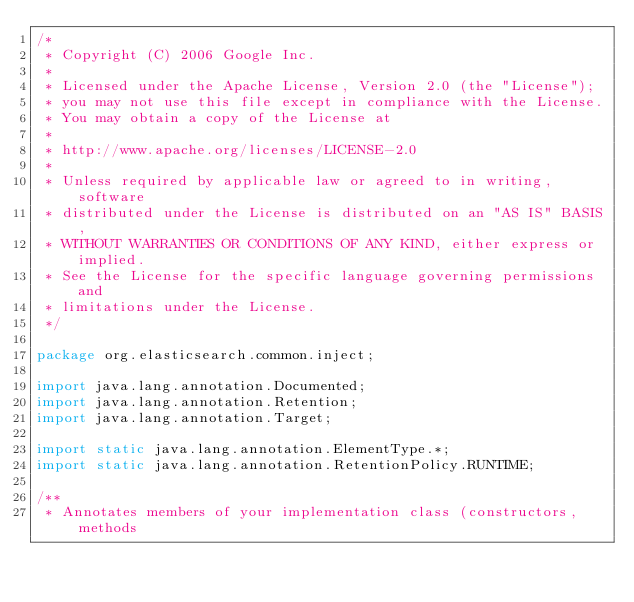<code> <loc_0><loc_0><loc_500><loc_500><_Java_>/*
 * Copyright (C) 2006 Google Inc.
 *
 * Licensed under the Apache License, Version 2.0 (the "License");
 * you may not use this file except in compliance with the License.
 * You may obtain a copy of the License at
 *
 * http://www.apache.org/licenses/LICENSE-2.0
 *
 * Unless required by applicable law or agreed to in writing, software
 * distributed under the License is distributed on an "AS IS" BASIS,
 * WITHOUT WARRANTIES OR CONDITIONS OF ANY KIND, either express or implied.
 * See the License for the specific language governing permissions and
 * limitations under the License.
 */

package org.elasticsearch.common.inject;

import java.lang.annotation.Documented;
import java.lang.annotation.Retention;
import java.lang.annotation.Target;

import static java.lang.annotation.ElementType.*;
import static java.lang.annotation.RetentionPolicy.RUNTIME;

/**
 * Annotates members of your implementation class (constructors, methods</code> 